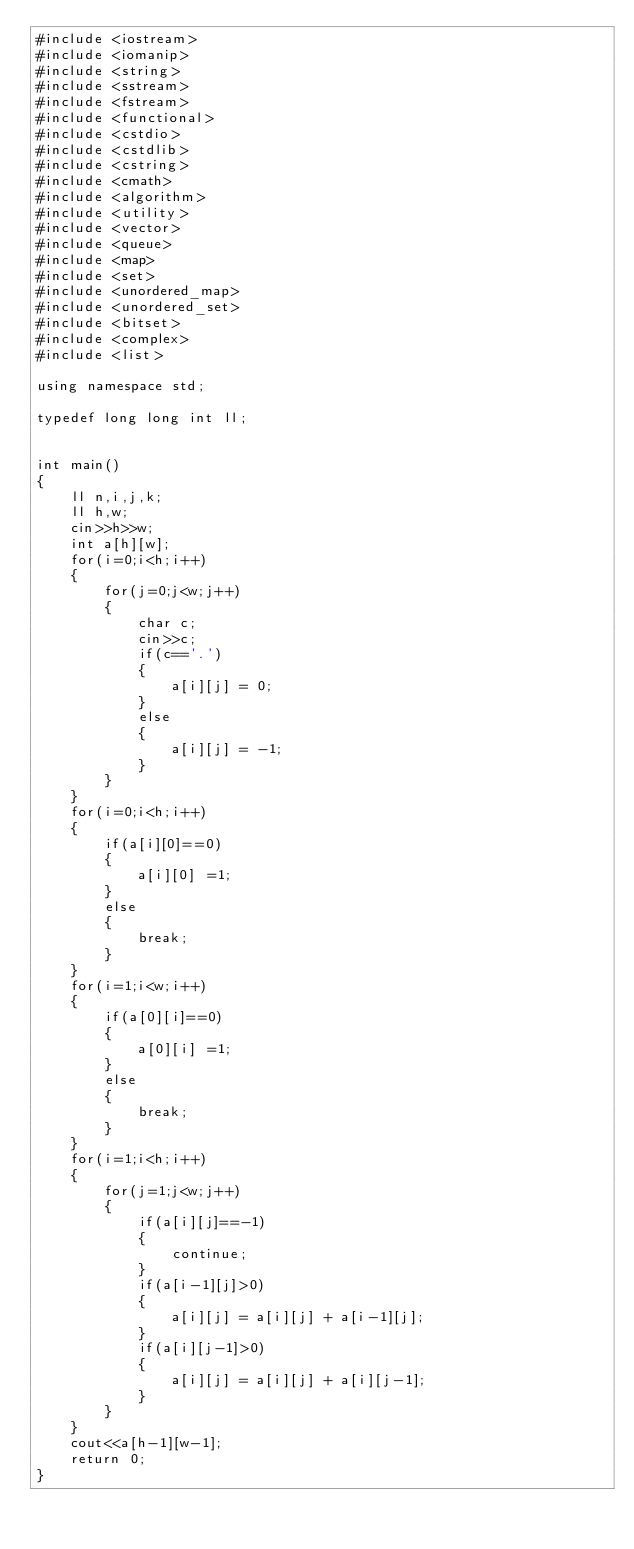<code> <loc_0><loc_0><loc_500><loc_500><_C++_>#include <iostream>
#include <iomanip>
#include <string>
#include <sstream>
#include <fstream>
#include <functional>
#include <cstdio>
#include <cstdlib>
#include <cstring>
#include <cmath>
#include <algorithm>
#include <utility>
#include <vector>
#include <queue>
#include <map>
#include <set>
#include <unordered_map>
#include <unordered_set>
#include <bitset>
#include <complex>
#include <list>

using namespace std; 

typedef long long int ll;


int main()
{
    ll n,i,j,k;
    ll h,w;
    cin>>h>>w;
    int a[h][w];
    for(i=0;i<h;i++)
    {
    	for(j=0;j<w;j++)
    	{
    		char c;
    		cin>>c;
    		if(c=='.')
    		{
    			a[i][j] = 0;
    		}
    		else
    		{
    			a[i][j] = -1;
    		}
    	}
    }
    for(i=0;i<h;i++)
    {
    	if(a[i][0]==0)
    	{
    		a[i][0] =1;
    	}
    	else
    	{
    		break;
    	}
    }
    for(i=1;i<w;i++)
    {
    	if(a[0][i]==0)
    	{
    		a[0][i] =1;
    	}
    	else
    	{
    		break;
    	}
    }
    for(i=1;i<h;i++)
    {
    	for(j=1;j<w;j++)
    	{
    		if(a[i][j]==-1)
    		{
    			continue;
    		}
    		if(a[i-1][j]>0)
    		{
    			a[i][j] = a[i][j] + a[i-1][j];
    		}
    		if(a[i][j-1]>0)
    		{
    			a[i][j] = a[i][j] + a[i][j-1];
    		}
    	}
    }
    cout<<a[h-1][w-1];
    return 0;
}</code> 